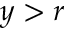<formula> <loc_0><loc_0><loc_500><loc_500>y > r</formula> 